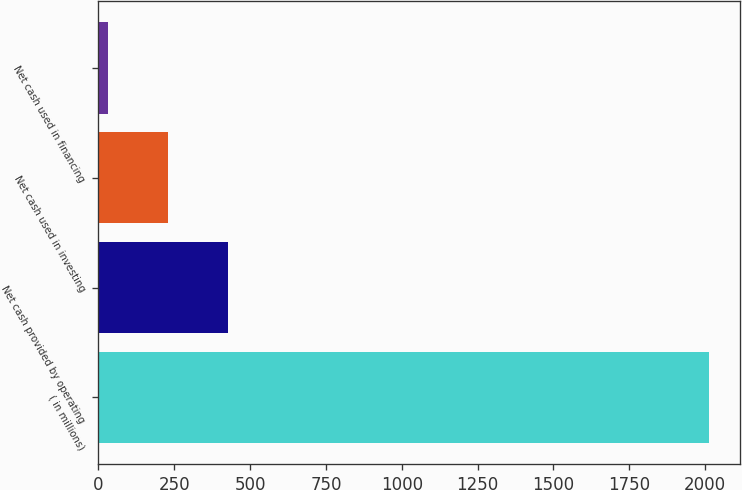Convert chart. <chart><loc_0><loc_0><loc_500><loc_500><bar_chart><fcel>( in millions)<fcel>Net cash provided by operating<fcel>Net cash used in investing<fcel>Net cash used in financing<nl><fcel>2014<fcel>427.44<fcel>229.12<fcel>30.8<nl></chart> 